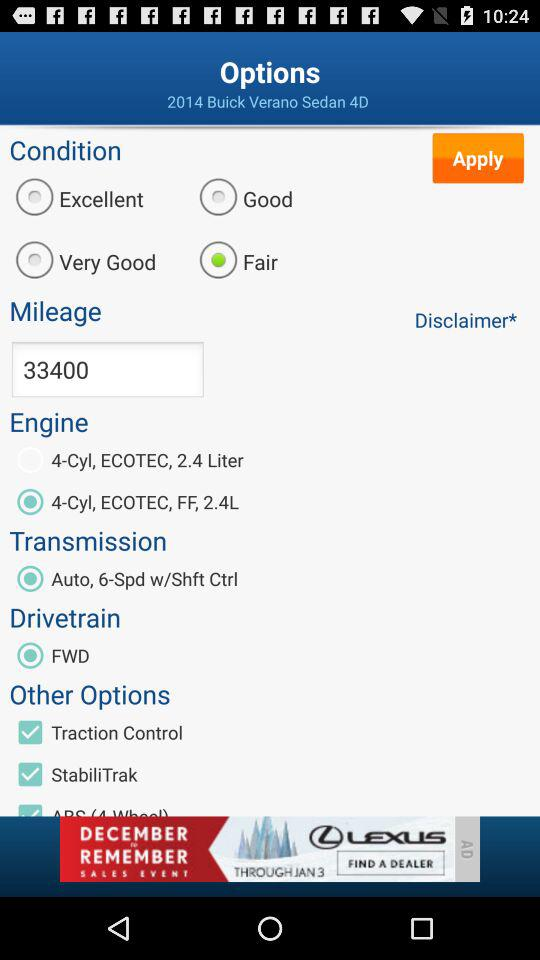What is the mileage? The mileage is 33400. 